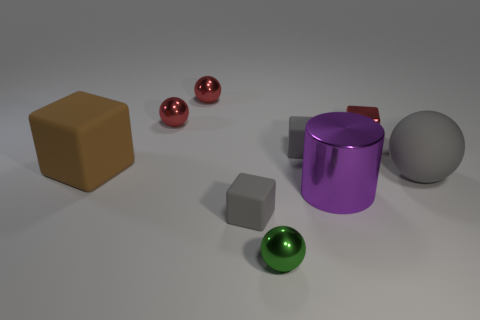Subtract all red balls. How many were subtracted if there are1red balls left? 1 Subtract all gray rubber spheres. How many spheres are left? 3 Add 1 small blocks. How many objects exist? 10 Subtract all red balls. How many balls are left? 2 Subtract 1 cylinders. How many cylinders are left? 0 Subtract 0 brown spheres. How many objects are left? 9 Subtract all balls. How many objects are left? 5 Subtract all red cylinders. Subtract all green spheres. How many cylinders are left? 1 Subtract all blue spheres. How many red cubes are left? 1 Subtract all big gray spheres. Subtract all metal objects. How many objects are left? 3 